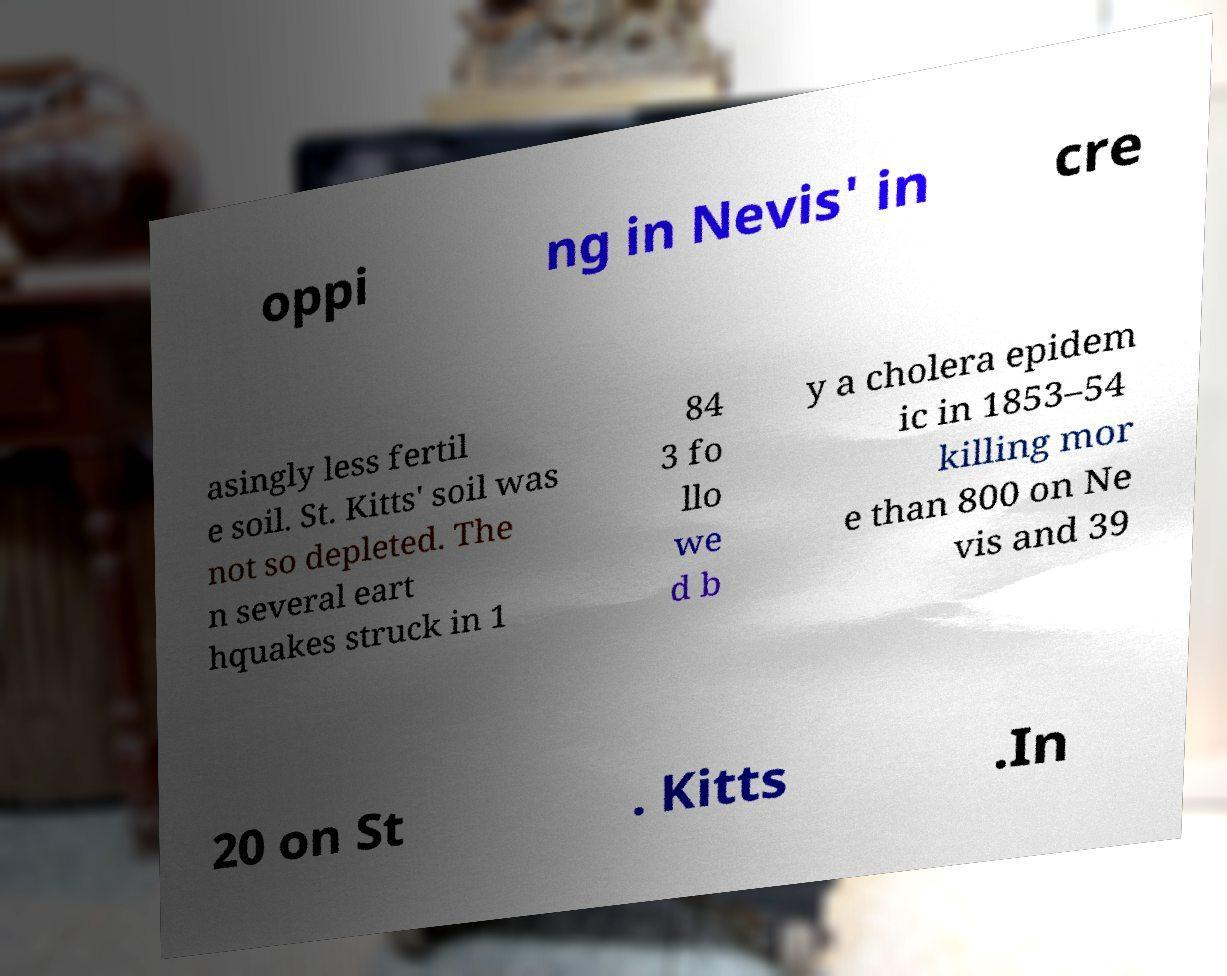Could you extract and type out the text from this image? oppi ng in Nevis' in cre asingly less fertil e soil. St. Kitts' soil was not so depleted. The n several eart hquakes struck in 1 84 3 fo llo we d b y a cholera epidem ic in 1853–54 killing mor e than 800 on Ne vis and 39 20 on St . Kitts .In 